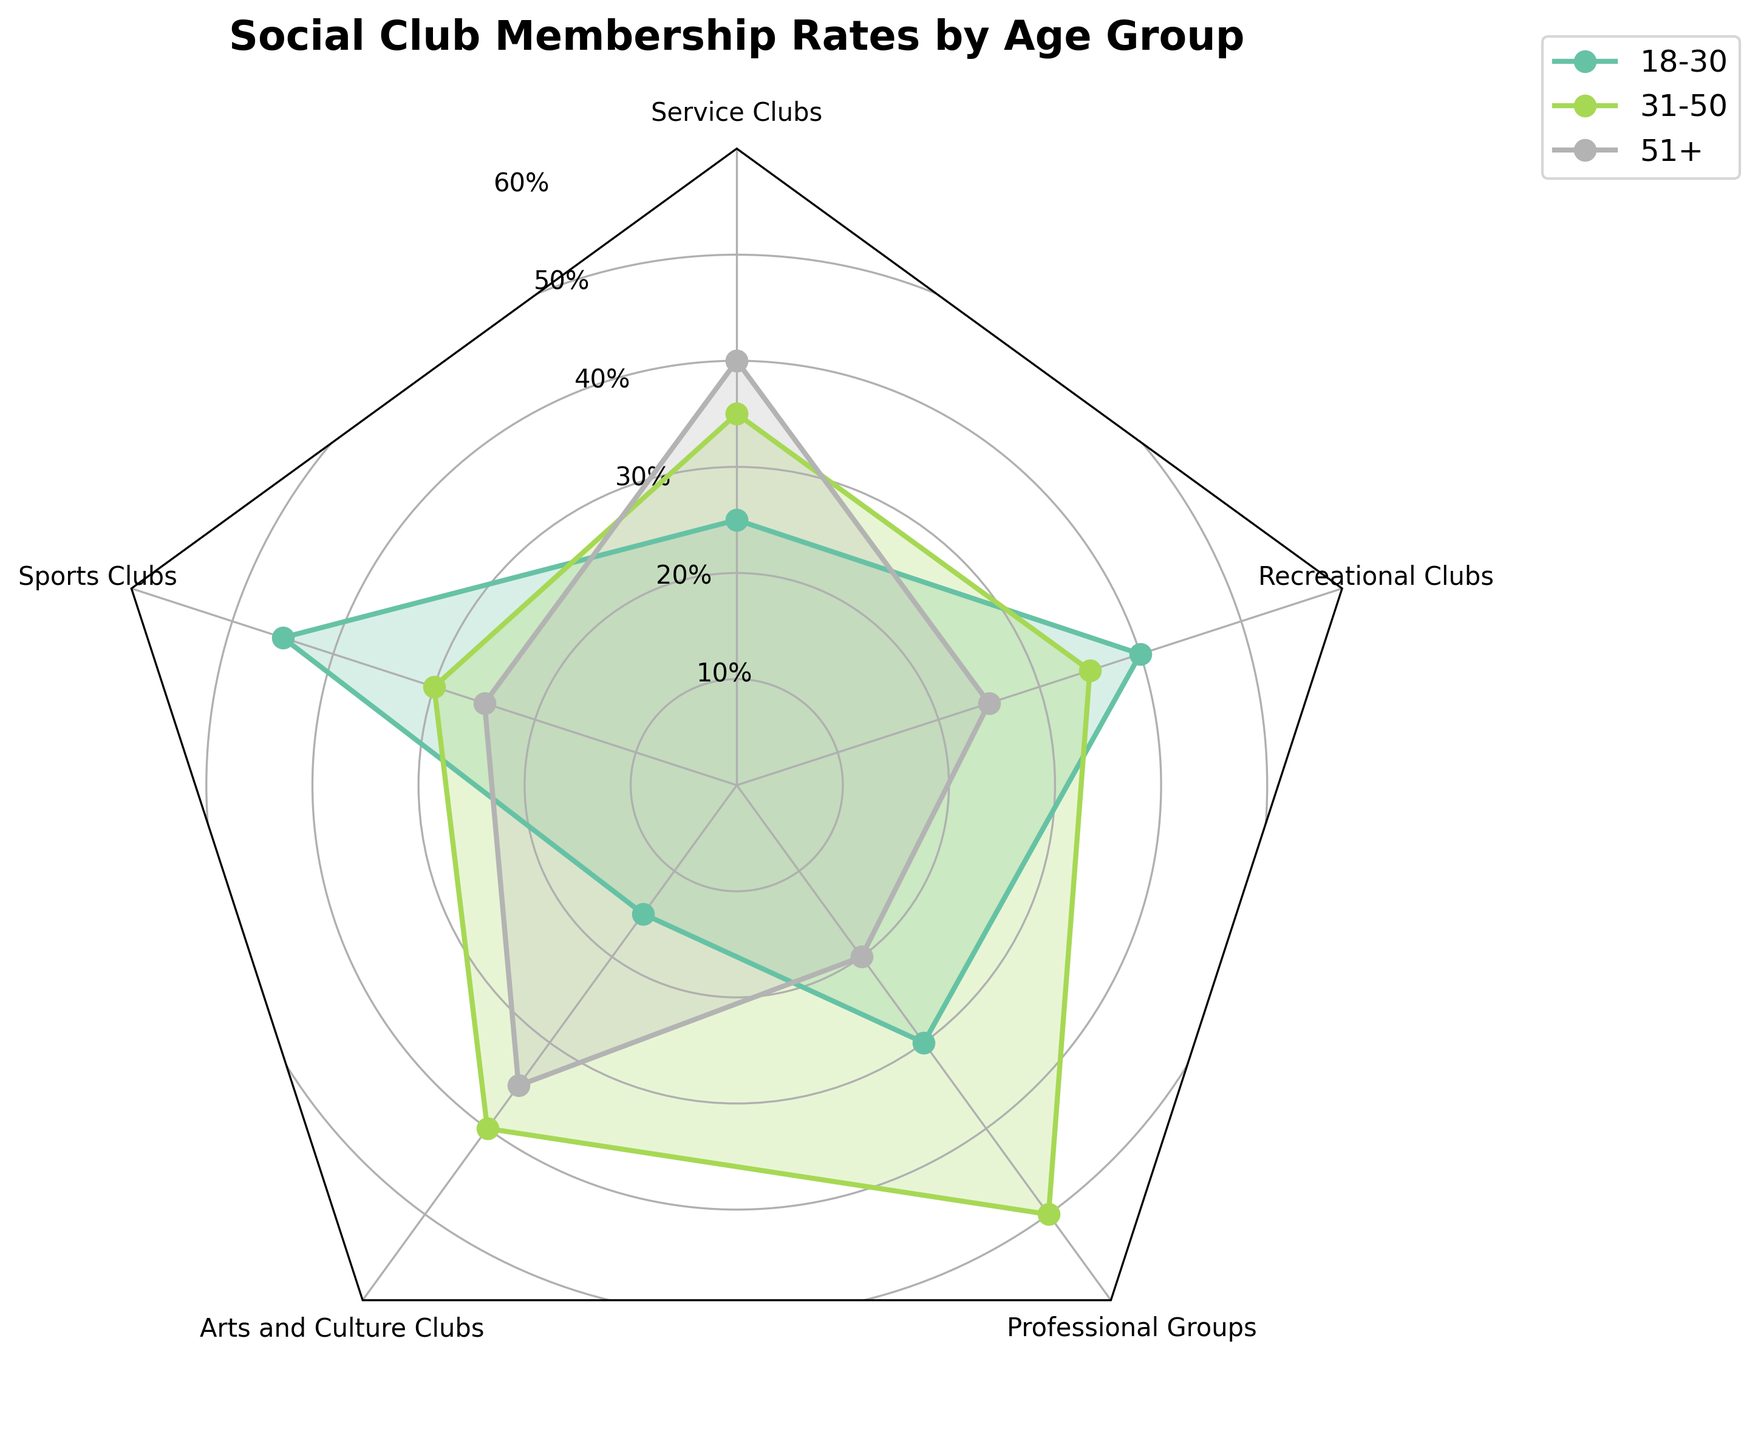What is the title of the radar chart? The title of the radar chart is typically found at the top center. It helps the viewer understand what the chart represents.
Answer: Social Club Membership Rates by Age Group Which age group has the highest membership rate in Service Clubs? To find the highest membership rate in Service Clubs, look at the Service Clubs section and compare the membership rates for different age groups. The 51+ age group has the highest rate.
Answer: 51+ What is the membership rate difference between the 18-30 and 31-50 age groups in Sports Clubs? Find the membership rates for both age groups in Sports Clubs, then subtract the smaller rate (31-50 at 30%) from the larger rate (18-30 at 45%).
Answer: 15% Which club type shows a relatively equal membership rate across all age groups? Compare the membership rates across all age groups for each club type. Recreational Clubs have relatively balanced rates of 40%, 35%, and 25% across the age groups 18-30, 31-50, and 51+, respectively.
Answer: Recreational Clubs In which age group does Arts and Culture Clubs have the highest membership rate? Locate the section for Arts and Culture Clubs and identify the highest membership rate across the age groups. The 31-50 age group has the highest membership rate at 40%.
Answer: 31-50 What is the average membership rate in Professional Groups across all age groups? Add up the membership rates for all age groups in Professional Groups and divide by the number of age groups: (30% + 50% + 20%) / 3.
Answer: 33.33% Which age group has the widest range of membership rates across all club types? Calculate the difference between the maximum and minimum membership rates for each age group across all club types. The 18-30 age group has the widest range (45% - 15% = 30%).
Answer: 18-30 How does the membership rate of 18-30 in Service Clubs compare with the rate in Professional Groups? Look at the membership rates for 18-30 in both Service Clubs (25%) and Professional Groups (30%) and compare them, noting that Professional Groups have a higher rate.
Answer: Professional Groups is higher by 5% Which club type has the lowest overall membership rate for the 51+ age group? Identify the membership rate for the 51+ age group in each club type and find the lowest one. Professional Groups have the lowest rate at 20%.
Answer: Professional Groups What is the sum of the membership rates for 31-50 age group across all club types? Add the membership rates for the 31-50 age group across all club types: 35% (Service) + 30% (Sports) + 40% (Arts) + 50% (Professional) + 35% (Recreational).
Answer: 190% 